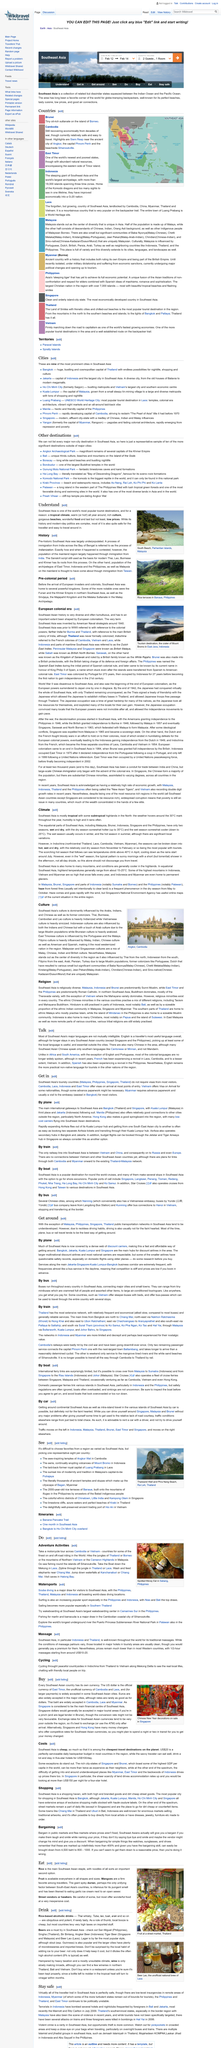Highlight a few significant elements in this photo. The influence of American culture on Filipino culture is undeniable, as it is evident in various aspects such as language, food, and music. Malaysian culture is influenced by Turkey to some extent. The climate in Southeast Asia is characterized by being tropical, with hot and humid temperatures year-round. According to the article "Do," Cambodia and Vietnam are countries that offer some of the finest on and off-road riding in the world. In this article, motorcycle riding, sea fishing, and zip lining are described as adventure activities. 